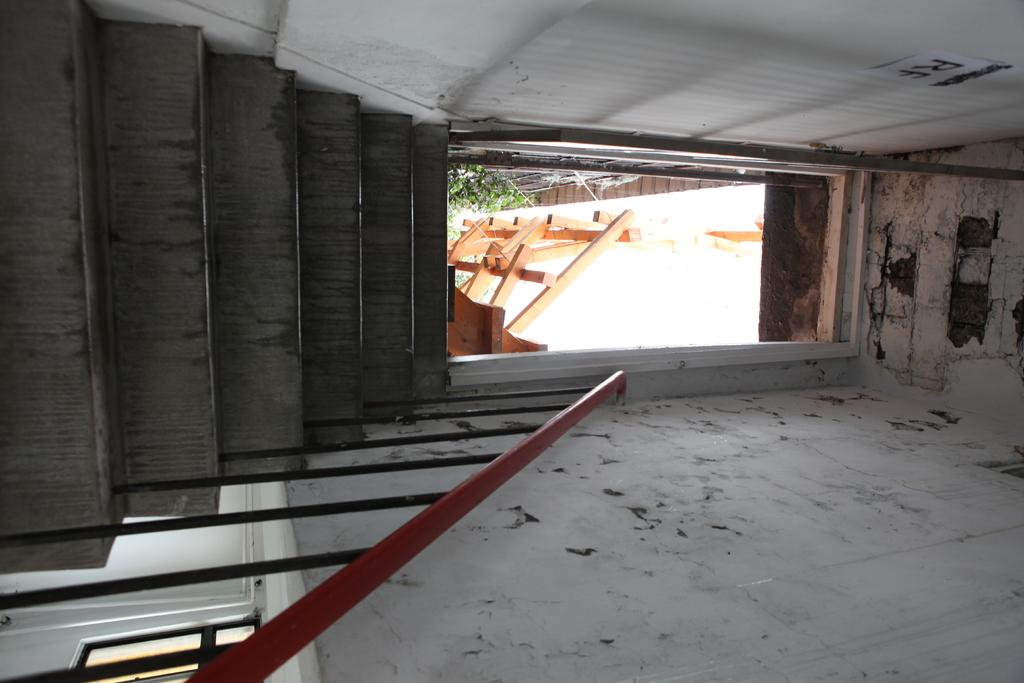What type of architectural feature is present in the image? There are: There are stairs in the image. What safety feature is present alongside the stairs? There is a railing in the image. What can be used to enter or exit a room in the image? There is a door in the image. What encloses the space in the image? There are walls in the image. How many oranges are present on the stairs in the image? There are no oranges present in the image; it only features stairs, a railing, a door, and walls. 